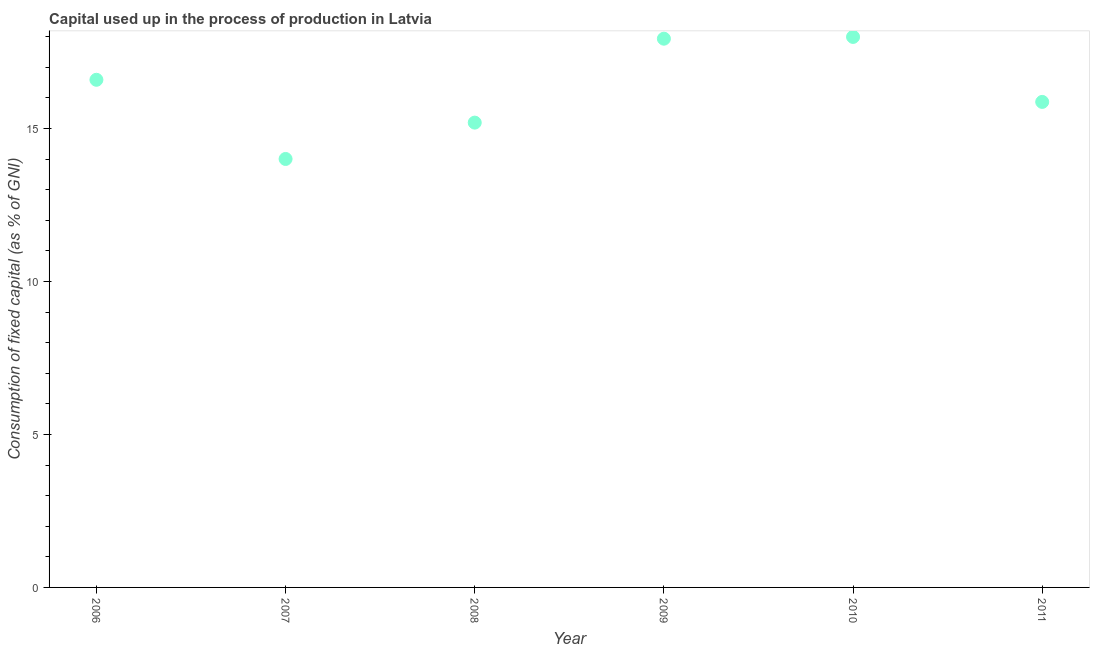What is the consumption of fixed capital in 2007?
Keep it short and to the point. 14. Across all years, what is the maximum consumption of fixed capital?
Give a very brief answer. 17.99. Across all years, what is the minimum consumption of fixed capital?
Make the answer very short. 14. What is the sum of the consumption of fixed capital?
Your answer should be very brief. 97.57. What is the difference between the consumption of fixed capital in 2008 and 2010?
Offer a terse response. -2.8. What is the average consumption of fixed capital per year?
Offer a terse response. 16.26. What is the median consumption of fixed capital?
Your answer should be very brief. 16.23. What is the ratio of the consumption of fixed capital in 2008 to that in 2011?
Give a very brief answer. 0.96. Is the consumption of fixed capital in 2006 less than that in 2009?
Offer a terse response. Yes. What is the difference between the highest and the second highest consumption of fixed capital?
Provide a short and direct response. 0.06. What is the difference between the highest and the lowest consumption of fixed capital?
Provide a succinct answer. 3.99. Does the consumption of fixed capital monotonically increase over the years?
Ensure brevity in your answer.  No. How many dotlines are there?
Make the answer very short. 1. How many years are there in the graph?
Your response must be concise. 6. Does the graph contain grids?
Provide a succinct answer. No. What is the title of the graph?
Make the answer very short. Capital used up in the process of production in Latvia. What is the label or title of the X-axis?
Your response must be concise. Year. What is the label or title of the Y-axis?
Keep it short and to the point. Consumption of fixed capital (as % of GNI). What is the Consumption of fixed capital (as % of GNI) in 2006?
Offer a very short reply. 16.59. What is the Consumption of fixed capital (as % of GNI) in 2007?
Give a very brief answer. 14. What is the Consumption of fixed capital (as % of GNI) in 2008?
Offer a very short reply. 15.19. What is the Consumption of fixed capital (as % of GNI) in 2009?
Make the answer very short. 17.93. What is the Consumption of fixed capital (as % of GNI) in 2010?
Provide a succinct answer. 17.99. What is the Consumption of fixed capital (as % of GNI) in 2011?
Make the answer very short. 15.87. What is the difference between the Consumption of fixed capital (as % of GNI) in 2006 and 2007?
Ensure brevity in your answer.  2.59. What is the difference between the Consumption of fixed capital (as % of GNI) in 2006 and 2008?
Keep it short and to the point. 1.4. What is the difference between the Consumption of fixed capital (as % of GNI) in 2006 and 2009?
Keep it short and to the point. -1.34. What is the difference between the Consumption of fixed capital (as % of GNI) in 2006 and 2010?
Make the answer very short. -1.4. What is the difference between the Consumption of fixed capital (as % of GNI) in 2006 and 2011?
Your answer should be very brief. 0.72. What is the difference between the Consumption of fixed capital (as % of GNI) in 2007 and 2008?
Ensure brevity in your answer.  -1.19. What is the difference between the Consumption of fixed capital (as % of GNI) in 2007 and 2009?
Your response must be concise. -3.93. What is the difference between the Consumption of fixed capital (as % of GNI) in 2007 and 2010?
Your response must be concise. -3.99. What is the difference between the Consumption of fixed capital (as % of GNI) in 2007 and 2011?
Provide a succinct answer. -1.86. What is the difference between the Consumption of fixed capital (as % of GNI) in 2008 and 2009?
Give a very brief answer. -2.74. What is the difference between the Consumption of fixed capital (as % of GNI) in 2008 and 2010?
Provide a succinct answer. -2.8. What is the difference between the Consumption of fixed capital (as % of GNI) in 2008 and 2011?
Provide a short and direct response. -0.68. What is the difference between the Consumption of fixed capital (as % of GNI) in 2009 and 2010?
Give a very brief answer. -0.06. What is the difference between the Consumption of fixed capital (as % of GNI) in 2009 and 2011?
Your response must be concise. 2.07. What is the difference between the Consumption of fixed capital (as % of GNI) in 2010 and 2011?
Your response must be concise. 2.12. What is the ratio of the Consumption of fixed capital (as % of GNI) in 2006 to that in 2007?
Provide a short and direct response. 1.19. What is the ratio of the Consumption of fixed capital (as % of GNI) in 2006 to that in 2008?
Your response must be concise. 1.09. What is the ratio of the Consumption of fixed capital (as % of GNI) in 2006 to that in 2009?
Offer a very short reply. 0.93. What is the ratio of the Consumption of fixed capital (as % of GNI) in 2006 to that in 2010?
Ensure brevity in your answer.  0.92. What is the ratio of the Consumption of fixed capital (as % of GNI) in 2006 to that in 2011?
Make the answer very short. 1.05. What is the ratio of the Consumption of fixed capital (as % of GNI) in 2007 to that in 2008?
Give a very brief answer. 0.92. What is the ratio of the Consumption of fixed capital (as % of GNI) in 2007 to that in 2009?
Offer a very short reply. 0.78. What is the ratio of the Consumption of fixed capital (as % of GNI) in 2007 to that in 2010?
Your answer should be very brief. 0.78. What is the ratio of the Consumption of fixed capital (as % of GNI) in 2007 to that in 2011?
Provide a succinct answer. 0.88. What is the ratio of the Consumption of fixed capital (as % of GNI) in 2008 to that in 2009?
Give a very brief answer. 0.85. What is the ratio of the Consumption of fixed capital (as % of GNI) in 2008 to that in 2010?
Make the answer very short. 0.84. What is the ratio of the Consumption of fixed capital (as % of GNI) in 2009 to that in 2011?
Your response must be concise. 1.13. What is the ratio of the Consumption of fixed capital (as % of GNI) in 2010 to that in 2011?
Offer a terse response. 1.13. 